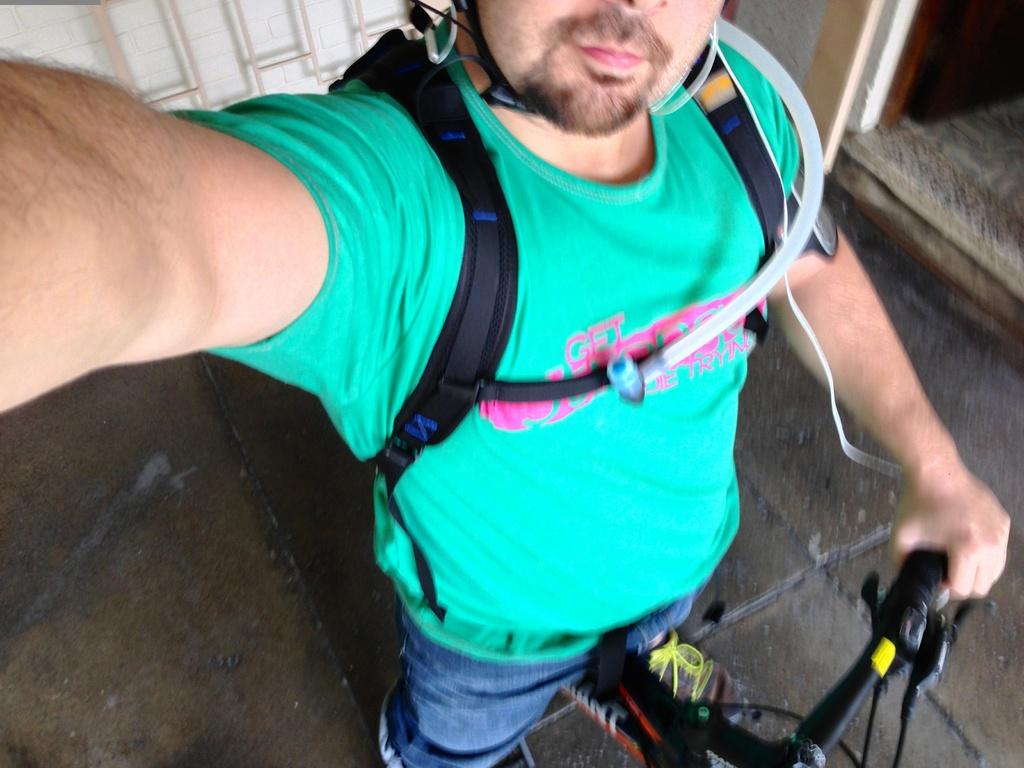Who is the main subject in the image? There is a man in the center of the image. What is the man wearing? The man is wearing a green t-shirt. What is the man holding in the image? The man is holding a bicycle. What is the man standing on? The man is standing on the floor. What else is the man carrying? The man is wearing a backpack. What can be seen in the background of the image? There is a wall in the background of the image. What type of art can be seen on the wall in the image? There is no art visible on the wall in the image. What type of milk is the man drinking in the image? There is no milk present in the image. 